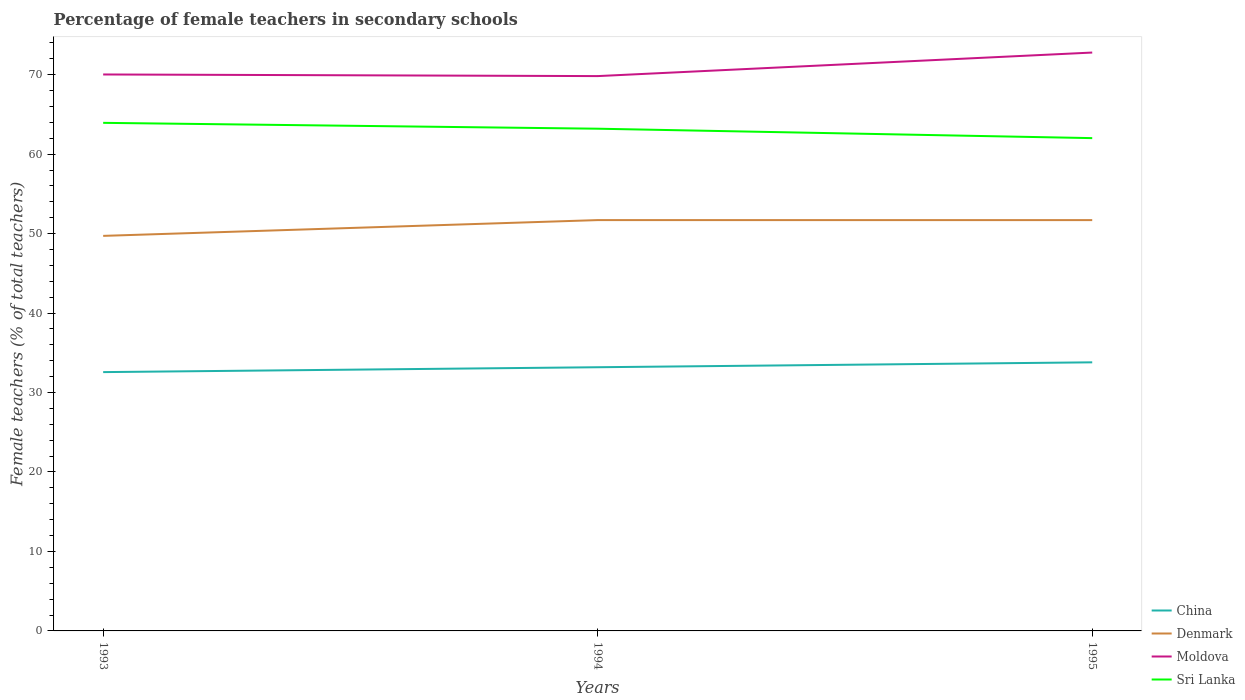How many different coloured lines are there?
Offer a terse response. 4. Across all years, what is the maximum percentage of female teachers in Sri Lanka?
Your response must be concise. 62.01. In which year was the percentage of female teachers in Denmark maximum?
Provide a short and direct response. 1993. What is the total percentage of female teachers in Sri Lanka in the graph?
Provide a succinct answer. 1.19. What is the difference between the highest and the second highest percentage of female teachers in Sri Lanka?
Your response must be concise. 1.92. Does the graph contain any zero values?
Offer a terse response. No. Where does the legend appear in the graph?
Keep it short and to the point. Bottom right. What is the title of the graph?
Provide a short and direct response. Percentage of female teachers in secondary schools. Does "American Samoa" appear as one of the legend labels in the graph?
Your answer should be very brief. No. What is the label or title of the Y-axis?
Give a very brief answer. Female teachers (% of total teachers). What is the Female teachers (% of total teachers) of China in 1993?
Provide a short and direct response. 32.57. What is the Female teachers (% of total teachers) of Denmark in 1993?
Make the answer very short. 49.71. What is the Female teachers (% of total teachers) of Moldova in 1993?
Give a very brief answer. 70.02. What is the Female teachers (% of total teachers) of Sri Lanka in 1993?
Keep it short and to the point. 63.94. What is the Female teachers (% of total teachers) of China in 1994?
Your response must be concise. 33.18. What is the Female teachers (% of total teachers) of Denmark in 1994?
Your answer should be compact. 51.7. What is the Female teachers (% of total teachers) of Moldova in 1994?
Provide a succinct answer. 69.82. What is the Female teachers (% of total teachers) of Sri Lanka in 1994?
Give a very brief answer. 63.2. What is the Female teachers (% of total teachers) in China in 1995?
Offer a terse response. 33.8. What is the Female teachers (% of total teachers) in Denmark in 1995?
Provide a succinct answer. 51.7. What is the Female teachers (% of total teachers) in Moldova in 1995?
Your response must be concise. 72.78. What is the Female teachers (% of total teachers) of Sri Lanka in 1995?
Provide a succinct answer. 62.01. Across all years, what is the maximum Female teachers (% of total teachers) in China?
Make the answer very short. 33.8. Across all years, what is the maximum Female teachers (% of total teachers) of Denmark?
Offer a terse response. 51.7. Across all years, what is the maximum Female teachers (% of total teachers) in Moldova?
Make the answer very short. 72.78. Across all years, what is the maximum Female teachers (% of total teachers) in Sri Lanka?
Offer a very short reply. 63.94. Across all years, what is the minimum Female teachers (% of total teachers) of China?
Offer a very short reply. 32.57. Across all years, what is the minimum Female teachers (% of total teachers) of Denmark?
Offer a terse response. 49.71. Across all years, what is the minimum Female teachers (% of total teachers) in Moldova?
Offer a very short reply. 69.82. Across all years, what is the minimum Female teachers (% of total teachers) in Sri Lanka?
Offer a very short reply. 62.01. What is the total Female teachers (% of total teachers) of China in the graph?
Your answer should be very brief. 99.55. What is the total Female teachers (% of total teachers) of Denmark in the graph?
Offer a terse response. 153.11. What is the total Female teachers (% of total teachers) in Moldova in the graph?
Give a very brief answer. 212.63. What is the total Female teachers (% of total teachers) of Sri Lanka in the graph?
Provide a short and direct response. 189.15. What is the difference between the Female teachers (% of total teachers) in China in 1993 and that in 1994?
Your answer should be very brief. -0.61. What is the difference between the Female teachers (% of total teachers) in Denmark in 1993 and that in 1994?
Make the answer very short. -1.99. What is the difference between the Female teachers (% of total teachers) of Moldova in 1993 and that in 1994?
Give a very brief answer. 0.21. What is the difference between the Female teachers (% of total teachers) of Sri Lanka in 1993 and that in 1994?
Give a very brief answer. 0.74. What is the difference between the Female teachers (% of total teachers) of China in 1993 and that in 1995?
Offer a very short reply. -1.23. What is the difference between the Female teachers (% of total teachers) of Denmark in 1993 and that in 1995?
Your answer should be very brief. -1.98. What is the difference between the Female teachers (% of total teachers) of Moldova in 1993 and that in 1995?
Make the answer very short. -2.76. What is the difference between the Female teachers (% of total teachers) of Sri Lanka in 1993 and that in 1995?
Your answer should be very brief. 1.92. What is the difference between the Female teachers (% of total teachers) in China in 1994 and that in 1995?
Offer a terse response. -0.62. What is the difference between the Female teachers (% of total teachers) of Denmark in 1994 and that in 1995?
Give a very brief answer. 0. What is the difference between the Female teachers (% of total teachers) of Moldova in 1994 and that in 1995?
Offer a very short reply. -2.96. What is the difference between the Female teachers (% of total teachers) in Sri Lanka in 1994 and that in 1995?
Keep it short and to the point. 1.19. What is the difference between the Female teachers (% of total teachers) of China in 1993 and the Female teachers (% of total teachers) of Denmark in 1994?
Keep it short and to the point. -19.13. What is the difference between the Female teachers (% of total teachers) of China in 1993 and the Female teachers (% of total teachers) of Moldova in 1994?
Your answer should be very brief. -37.25. What is the difference between the Female teachers (% of total teachers) of China in 1993 and the Female teachers (% of total teachers) of Sri Lanka in 1994?
Your answer should be compact. -30.63. What is the difference between the Female teachers (% of total teachers) in Denmark in 1993 and the Female teachers (% of total teachers) in Moldova in 1994?
Ensure brevity in your answer.  -20.11. What is the difference between the Female teachers (% of total teachers) in Denmark in 1993 and the Female teachers (% of total teachers) in Sri Lanka in 1994?
Make the answer very short. -13.49. What is the difference between the Female teachers (% of total teachers) of Moldova in 1993 and the Female teachers (% of total teachers) of Sri Lanka in 1994?
Provide a succinct answer. 6.82. What is the difference between the Female teachers (% of total teachers) in China in 1993 and the Female teachers (% of total teachers) in Denmark in 1995?
Give a very brief answer. -19.13. What is the difference between the Female teachers (% of total teachers) in China in 1993 and the Female teachers (% of total teachers) in Moldova in 1995?
Offer a terse response. -40.21. What is the difference between the Female teachers (% of total teachers) in China in 1993 and the Female teachers (% of total teachers) in Sri Lanka in 1995?
Provide a succinct answer. -29.44. What is the difference between the Female teachers (% of total teachers) in Denmark in 1993 and the Female teachers (% of total teachers) in Moldova in 1995?
Give a very brief answer. -23.07. What is the difference between the Female teachers (% of total teachers) in Denmark in 1993 and the Female teachers (% of total teachers) in Sri Lanka in 1995?
Offer a very short reply. -12.3. What is the difference between the Female teachers (% of total teachers) in Moldova in 1993 and the Female teachers (% of total teachers) in Sri Lanka in 1995?
Provide a short and direct response. 8.01. What is the difference between the Female teachers (% of total teachers) in China in 1994 and the Female teachers (% of total teachers) in Denmark in 1995?
Provide a succinct answer. -18.51. What is the difference between the Female teachers (% of total teachers) of China in 1994 and the Female teachers (% of total teachers) of Moldova in 1995?
Your answer should be compact. -39.6. What is the difference between the Female teachers (% of total teachers) in China in 1994 and the Female teachers (% of total teachers) in Sri Lanka in 1995?
Keep it short and to the point. -28.83. What is the difference between the Female teachers (% of total teachers) of Denmark in 1994 and the Female teachers (% of total teachers) of Moldova in 1995?
Your answer should be compact. -21.08. What is the difference between the Female teachers (% of total teachers) of Denmark in 1994 and the Female teachers (% of total teachers) of Sri Lanka in 1995?
Your response must be concise. -10.32. What is the difference between the Female teachers (% of total teachers) in Moldova in 1994 and the Female teachers (% of total teachers) in Sri Lanka in 1995?
Keep it short and to the point. 7.81. What is the average Female teachers (% of total teachers) of China per year?
Keep it short and to the point. 33.18. What is the average Female teachers (% of total teachers) of Denmark per year?
Make the answer very short. 51.04. What is the average Female teachers (% of total teachers) in Moldova per year?
Offer a very short reply. 70.88. What is the average Female teachers (% of total teachers) of Sri Lanka per year?
Give a very brief answer. 63.05. In the year 1993, what is the difference between the Female teachers (% of total teachers) in China and Female teachers (% of total teachers) in Denmark?
Offer a very short reply. -17.14. In the year 1993, what is the difference between the Female teachers (% of total teachers) in China and Female teachers (% of total teachers) in Moldova?
Offer a terse response. -37.46. In the year 1993, what is the difference between the Female teachers (% of total teachers) of China and Female teachers (% of total teachers) of Sri Lanka?
Make the answer very short. -31.37. In the year 1993, what is the difference between the Female teachers (% of total teachers) of Denmark and Female teachers (% of total teachers) of Moldova?
Provide a short and direct response. -20.31. In the year 1993, what is the difference between the Female teachers (% of total teachers) of Denmark and Female teachers (% of total teachers) of Sri Lanka?
Your answer should be very brief. -14.23. In the year 1993, what is the difference between the Female teachers (% of total teachers) in Moldova and Female teachers (% of total teachers) in Sri Lanka?
Make the answer very short. 6.09. In the year 1994, what is the difference between the Female teachers (% of total teachers) of China and Female teachers (% of total teachers) of Denmark?
Provide a succinct answer. -18.52. In the year 1994, what is the difference between the Female teachers (% of total teachers) of China and Female teachers (% of total teachers) of Moldova?
Offer a terse response. -36.64. In the year 1994, what is the difference between the Female teachers (% of total teachers) of China and Female teachers (% of total teachers) of Sri Lanka?
Provide a succinct answer. -30.02. In the year 1994, what is the difference between the Female teachers (% of total teachers) of Denmark and Female teachers (% of total teachers) of Moldova?
Make the answer very short. -18.12. In the year 1994, what is the difference between the Female teachers (% of total teachers) of Denmark and Female teachers (% of total teachers) of Sri Lanka?
Provide a short and direct response. -11.5. In the year 1994, what is the difference between the Female teachers (% of total teachers) of Moldova and Female teachers (% of total teachers) of Sri Lanka?
Your answer should be compact. 6.62. In the year 1995, what is the difference between the Female teachers (% of total teachers) in China and Female teachers (% of total teachers) in Denmark?
Provide a short and direct response. -17.9. In the year 1995, what is the difference between the Female teachers (% of total teachers) of China and Female teachers (% of total teachers) of Moldova?
Provide a short and direct response. -38.98. In the year 1995, what is the difference between the Female teachers (% of total teachers) of China and Female teachers (% of total teachers) of Sri Lanka?
Offer a very short reply. -28.21. In the year 1995, what is the difference between the Female teachers (% of total teachers) in Denmark and Female teachers (% of total teachers) in Moldova?
Provide a succinct answer. -21.09. In the year 1995, what is the difference between the Female teachers (% of total teachers) of Denmark and Female teachers (% of total teachers) of Sri Lanka?
Offer a very short reply. -10.32. In the year 1995, what is the difference between the Female teachers (% of total teachers) of Moldova and Female teachers (% of total teachers) of Sri Lanka?
Offer a terse response. 10.77. What is the ratio of the Female teachers (% of total teachers) in China in 1993 to that in 1994?
Your answer should be compact. 0.98. What is the ratio of the Female teachers (% of total teachers) of Denmark in 1993 to that in 1994?
Provide a succinct answer. 0.96. What is the ratio of the Female teachers (% of total teachers) in Sri Lanka in 1993 to that in 1994?
Ensure brevity in your answer.  1.01. What is the ratio of the Female teachers (% of total teachers) in China in 1993 to that in 1995?
Make the answer very short. 0.96. What is the ratio of the Female teachers (% of total teachers) of Denmark in 1993 to that in 1995?
Ensure brevity in your answer.  0.96. What is the ratio of the Female teachers (% of total teachers) in Moldova in 1993 to that in 1995?
Your response must be concise. 0.96. What is the ratio of the Female teachers (% of total teachers) of Sri Lanka in 1993 to that in 1995?
Provide a short and direct response. 1.03. What is the ratio of the Female teachers (% of total teachers) in China in 1994 to that in 1995?
Provide a succinct answer. 0.98. What is the ratio of the Female teachers (% of total teachers) in Moldova in 1994 to that in 1995?
Your answer should be compact. 0.96. What is the ratio of the Female teachers (% of total teachers) of Sri Lanka in 1994 to that in 1995?
Your answer should be very brief. 1.02. What is the difference between the highest and the second highest Female teachers (% of total teachers) in China?
Make the answer very short. 0.62. What is the difference between the highest and the second highest Female teachers (% of total teachers) of Denmark?
Offer a very short reply. 0. What is the difference between the highest and the second highest Female teachers (% of total teachers) in Moldova?
Give a very brief answer. 2.76. What is the difference between the highest and the second highest Female teachers (% of total teachers) in Sri Lanka?
Keep it short and to the point. 0.74. What is the difference between the highest and the lowest Female teachers (% of total teachers) in China?
Provide a short and direct response. 1.23. What is the difference between the highest and the lowest Female teachers (% of total teachers) of Denmark?
Offer a very short reply. 1.99. What is the difference between the highest and the lowest Female teachers (% of total teachers) in Moldova?
Keep it short and to the point. 2.96. What is the difference between the highest and the lowest Female teachers (% of total teachers) of Sri Lanka?
Make the answer very short. 1.92. 